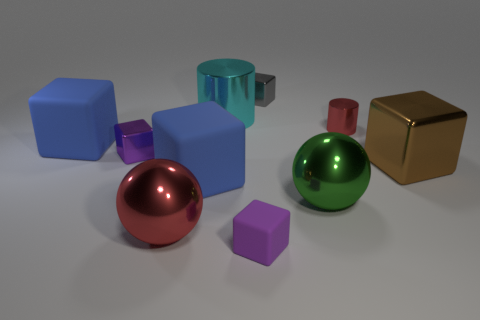There is a green sphere; how many big red shiny balls are on the right side of it?
Your response must be concise. 0. How many blocks are large blue objects or brown shiny things?
Provide a short and direct response. 3. What is the size of the metal cube that is on the right side of the small matte cube and behind the brown object?
Your answer should be very brief. Small. What number of other things are the same color as the large cylinder?
Offer a very short reply. 0. Is the material of the small gray thing the same as the large blue thing that is left of the tiny purple metal thing?
Offer a very short reply. No. What number of things are either purple cubes that are in front of the big brown block or matte blocks?
Give a very brief answer. 3. The rubber thing that is on the right side of the purple metal cube and behind the large red ball has what shape?
Your answer should be very brief. Cube. What size is the gray object that is the same material as the big green thing?
Your response must be concise. Small. How many objects are either tiny purple cubes in front of the brown cube or small objects on the right side of the small purple metallic object?
Make the answer very short. 3. Is the size of the object behind the cyan cylinder the same as the red cylinder?
Offer a terse response. Yes. 